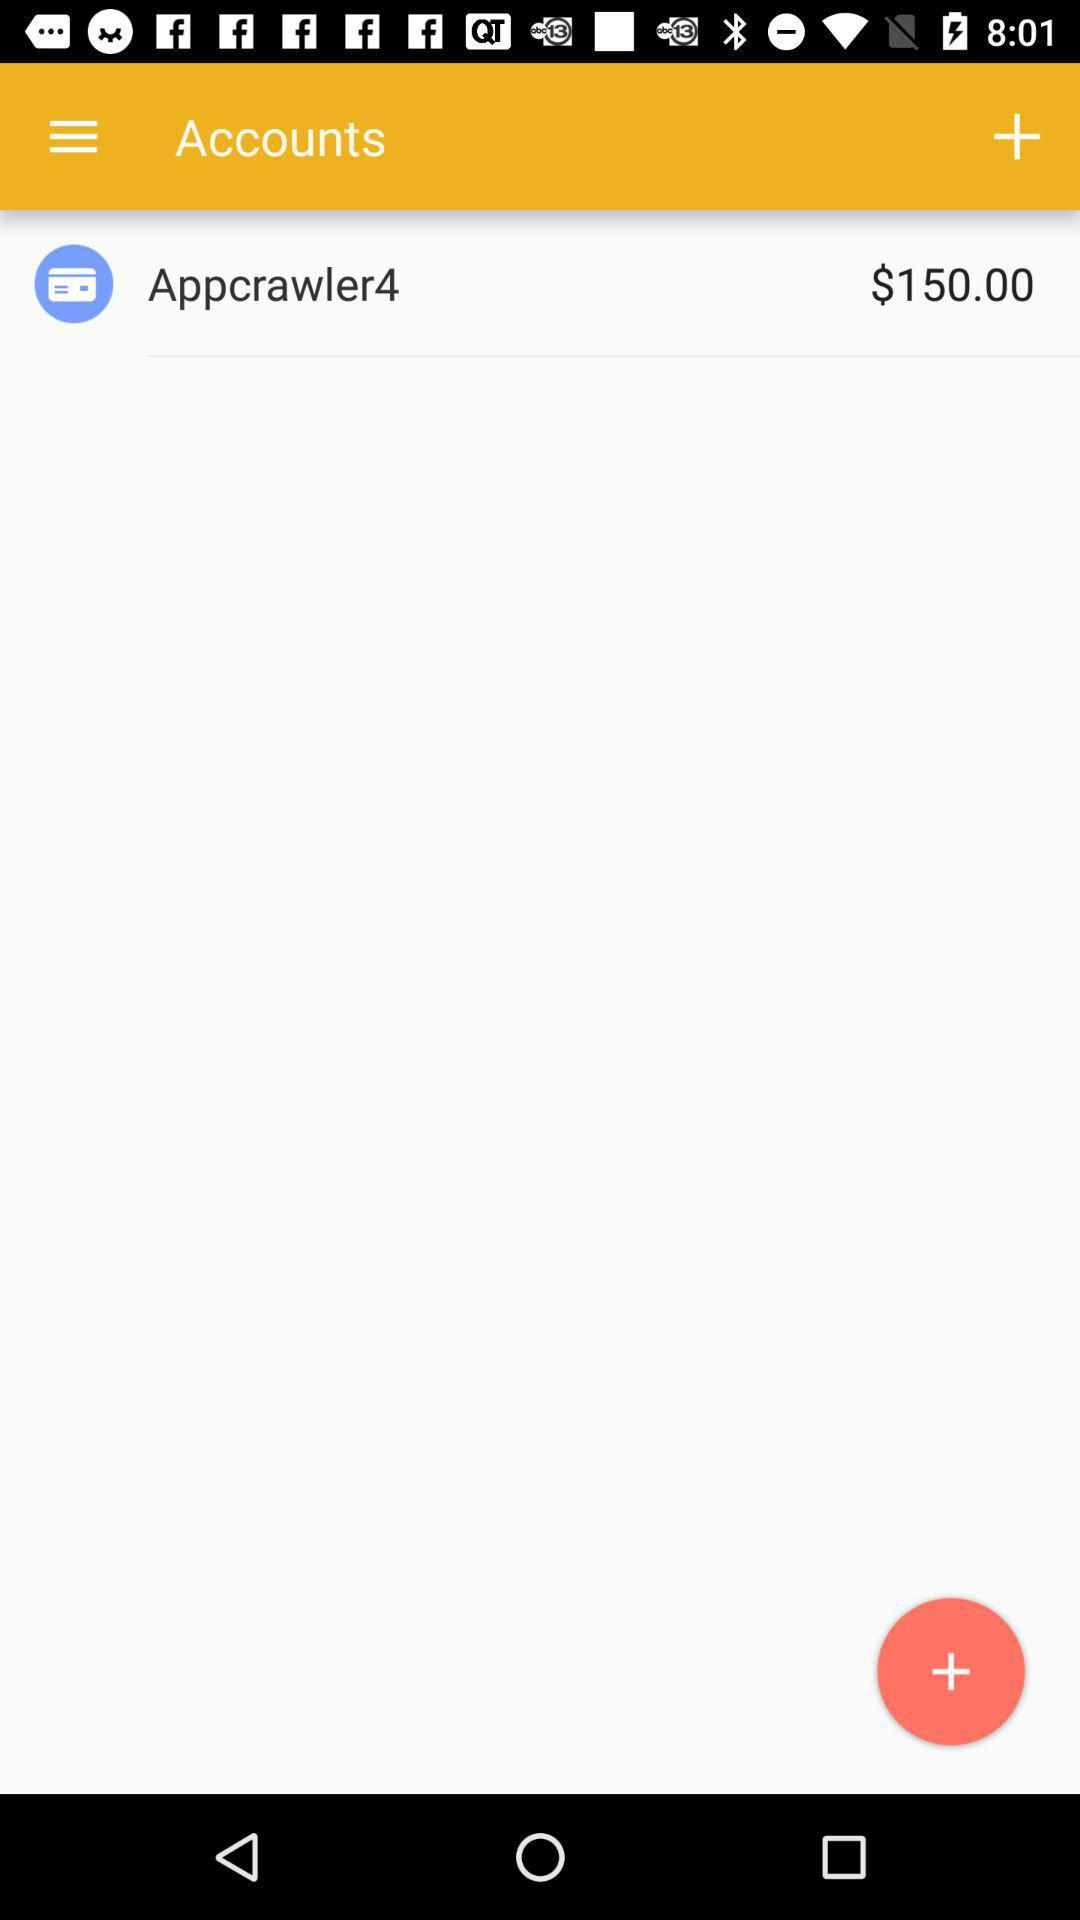How many dollars do I have in my account?
Answer the question using a single word or phrase. $150.00 